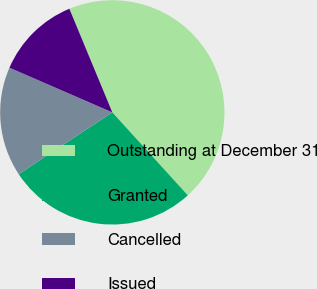Convert chart. <chart><loc_0><loc_0><loc_500><loc_500><pie_chart><fcel>Outstanding at December 31<fcel>Granted<fcel>Cancelled<fcel>Issued<nl><fcel>44.51%<fcel>27.46%<fcel>15.81%<fcel>12.22%<nl></chart> 